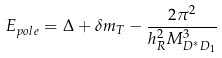Convert formula to latex. <formula><loc_0><loc_0><loc_500><loc_500>E _ { p o l e } = \Delta + \delta m _ { T } - \frac { 2 \pi ^ { 2 } } { h ^ { 2 } _ { R } M ^ { 3 } _ { D ^ { * } D _ { 1 } } }</formula> 